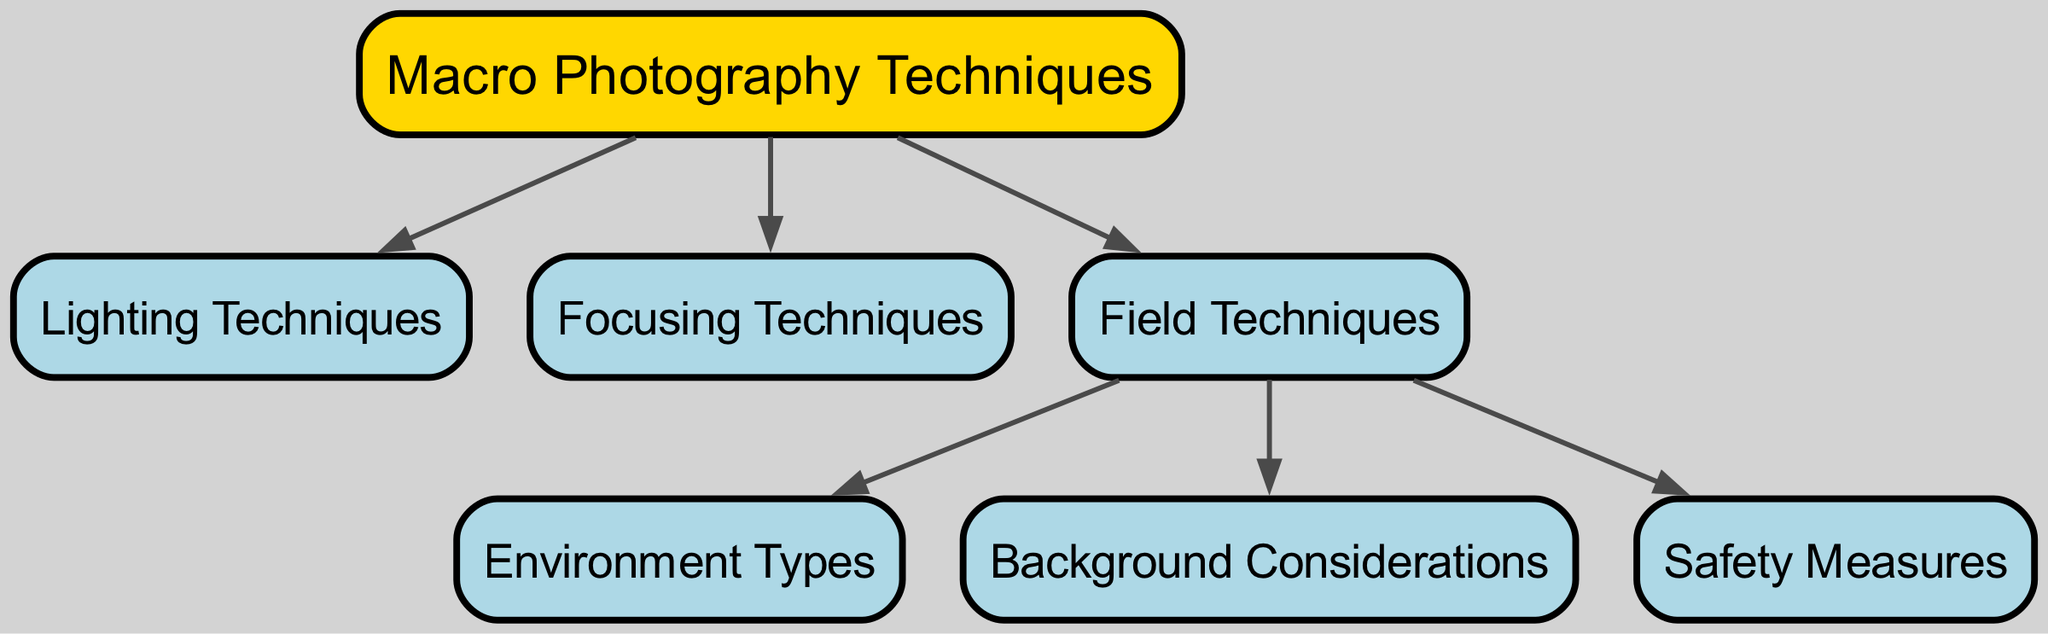What is the main topic of the diagram? The diagram focuses on "Macro Photography Techniques," which is clearly indicated as the main node.
Answer: Macro Photography Techniques How many nodes are present in the diagram? Counting each unique node listed, there are a total of 7 nodes in the diagram.
Answer: 7 Which technique is connected directly to "Safety Measures"? The only node that leads directly to "Safety Measures" is "Field Techniques."
Answer: Field Techniques What is the relationship between "Field Techniques" and "Environment Types"? "Field Techniques" points to "Environment Types," indicating that field techniques are related to different environment types in photography.
Answer: Field Techniques to Environment Types How many edges originate from "Macro Photography Techniques"? From the diagram edges, "Macro Photography Techniques" has 3 outgoing connections, leading to "Lighting Techniques," "Focusing Techniques," and "Field Techniques."
Answer: 3 Identify a node that connects "Background Considerations" and "Field Techniques." The node "Field Techniques" acts as a connecting point to "Background Considerations," demonstrating the relationship between the two.
Answer: Field Techniques Is there any node that connects to more than one other node? Yes, "Field Techniques" connects to three other nodes: "Environment Types," "Background Considerations," and "Safety Measures."
Answer: Yes What color is the main node in the diagram? The main node, "Macro Photography Techniques," is highlighted in a gold-like color, which is specified as '#ffd700' in the diagram styling.
Answer: Gold Which node represents techniques related to capturing insects? The node "Macro Photography Techniques" encompasses all methods specifically designed for insect photography.
Answer: Macro Photography Techniques 